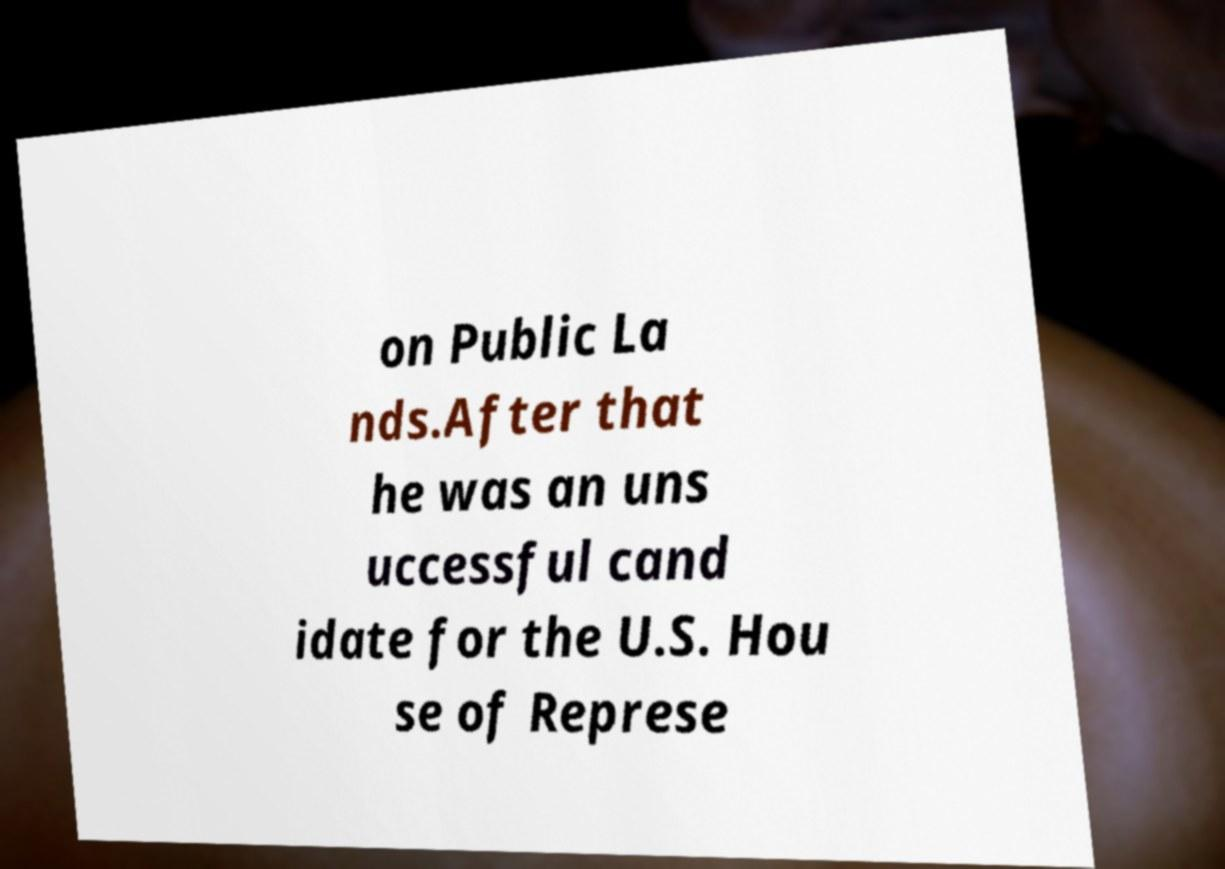There's text embedded in this image that I need extracted. Can you transcribe it verbatim? on Public La nds.After that he was an uns uccessful cand idate for the U.S. Hou se of Represe 